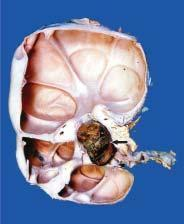s the glomeruli enlarged and heavy?
Answer the question using a single word or phrase. No 